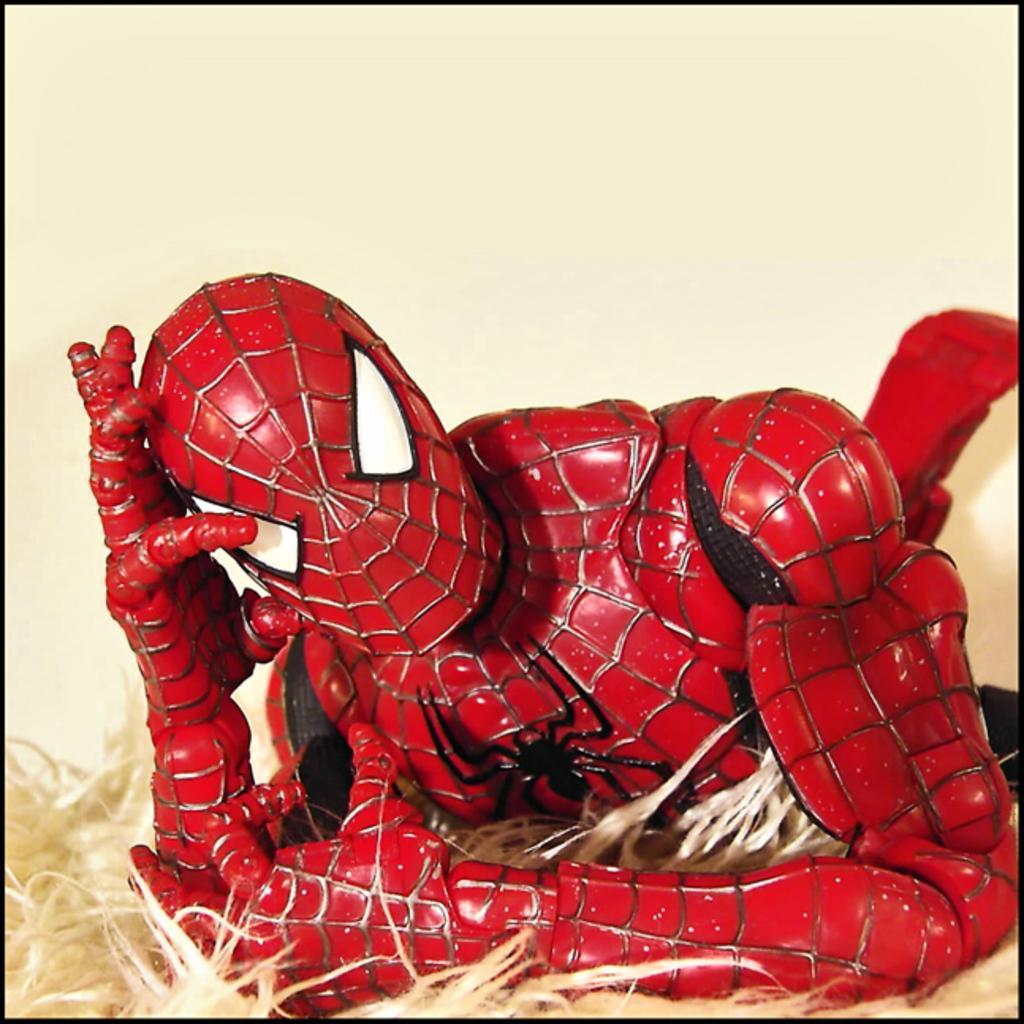Could you give a brief overview of what you see in this image? As we can see in the image there is a spider man statue and there is a wall. 